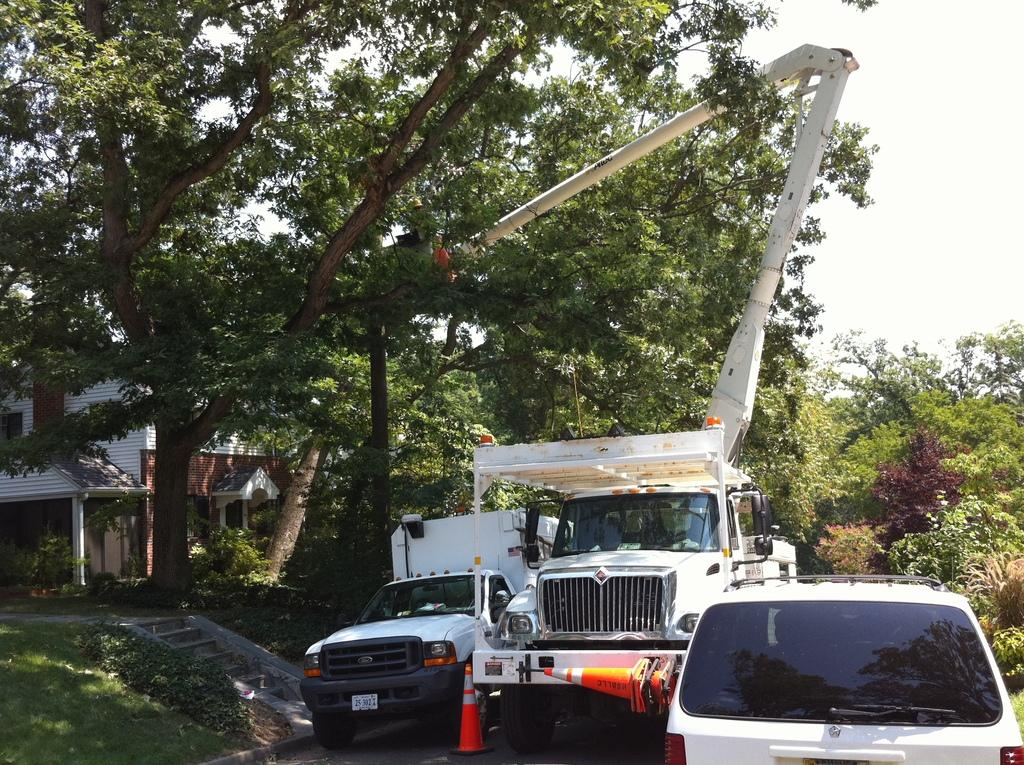What color are the vehicles in the image? The vehicles in the image are white. What other objects can be seen in the image? There are orange colored traffic cones in the image. What type of natural environment is visible in the image? There is grass visible in the image. What architectural feature can be seen in the image? There are stairs in the image. What type of structure is present in the image? There is a building in the image. What type of vegetation is visible in the image? There are trees in the image. How many dimes are scattered on the grass in the image? There are no dimes present in the image; it only features white vehicles, orange traffic cones, grass, stairs, a building, and trees. Can you describe the interaction between the friends in the image? There are no friends depicted in the image, as it only contains vehicles, traffic cones, grass, stairs, a building, and trees. 